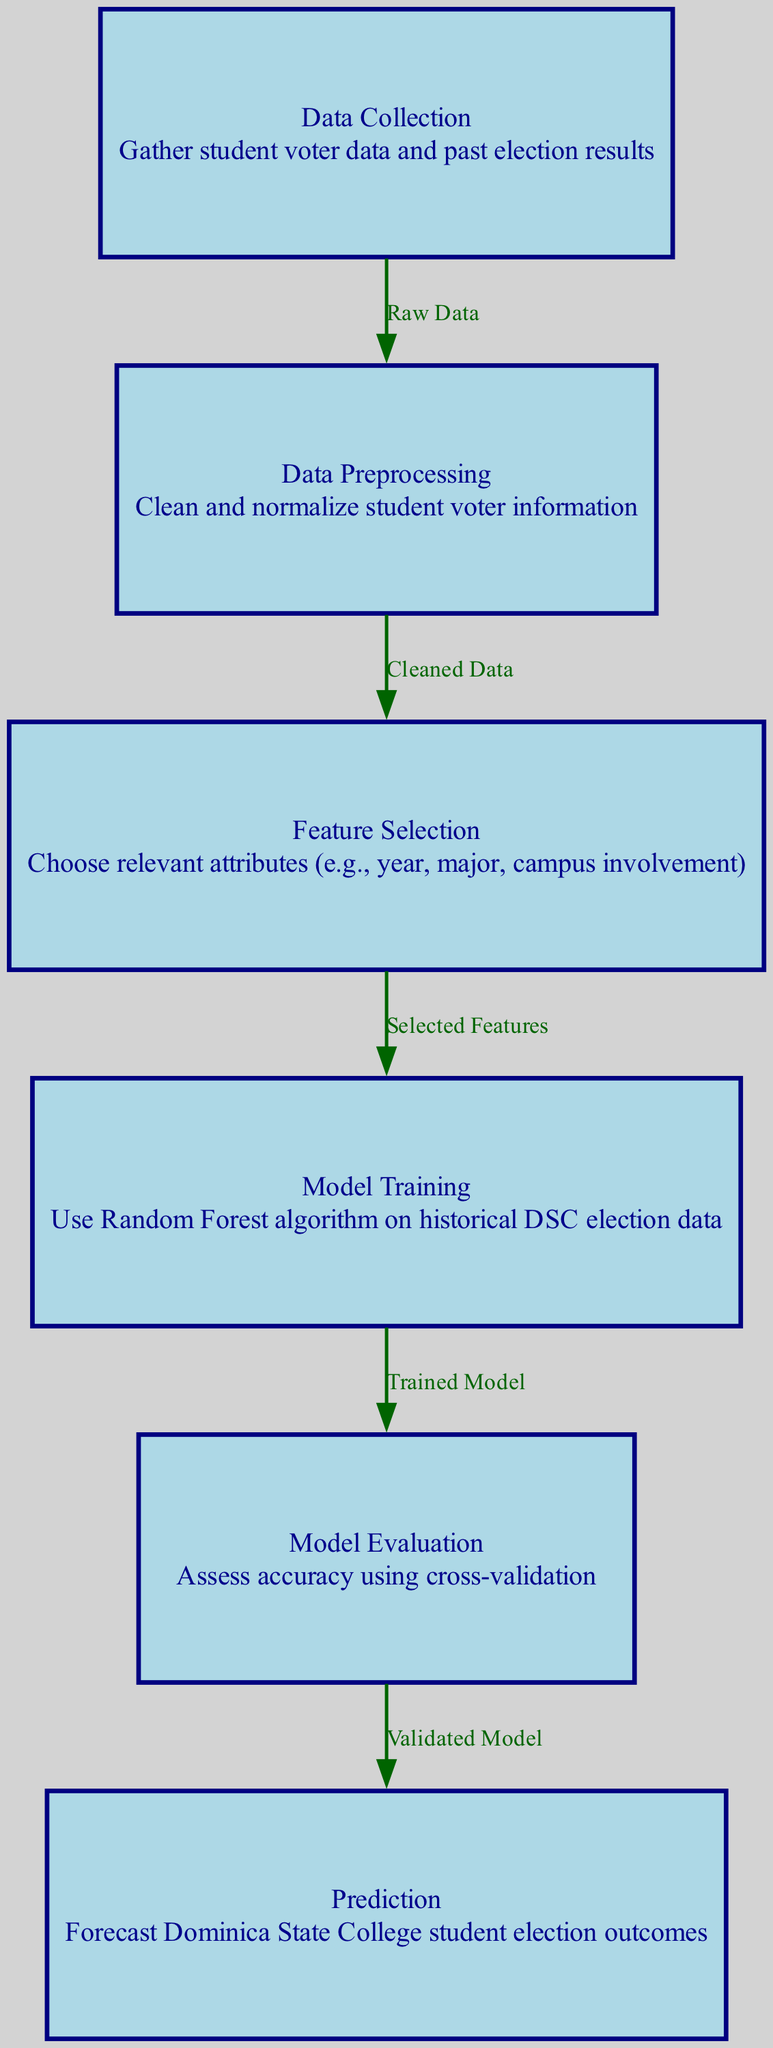What is the first node in the diagram? The first node in the diagram as indicated is "Data Collection," which is the starting point for the entire machine learning process.
Answer: Data Collection How many edges are in the diagram? By counting the connections between the nodes, there are five edges that represent the relationships or transitions from one process to another in the diagram.
Answer: 5 What is the last process in the flowchart? The last process indicated in the diagram is "Prediction," which represents the final outcome of the machine learning model.
Answer: Prediction Which node is evaluated after model training? The diagram indicates that "Model Evaluation" follows "Model Training," meaning that the accuracy of the model is assessed at this stage.
Answer: Model Evaluation What algorithm is used for model training? The diagram specifies the "Random Forest algorithm" as the technique employed during the model training phase of the process.
Answer: Random Forest algorithm What kind of data is transitioned from Data Preprocessing to Feature Selection? The transition between these nodes indicates that "Cleaned Data" is the type of data moved to the Feature Selection stage, derived from the preprocessed data.
Answer: Cleaned Data During what process are relevant attributes chosen? The diagram shows that relevant attributes are selected during the "Feature Selection" stage, which is critical for identifying useful input features for the model.
Answer: Feature Selection What is the purpose of Model Evaluation in this flowchart? Model Evaluation serves to "assess accuracy using cross-validation," which implies that this step is crucial for understanding how well the model performs against unseen data.
Answer: Assess accuracy using cross-validation What is the outcome of the entire machine learning process according to the diagram? The final outcome is represented as "Forecast Dominica State College student election outcomes," which summarizes the end result of the predictive model created.
Answer: Forecast Dominica State College student election outcomes 